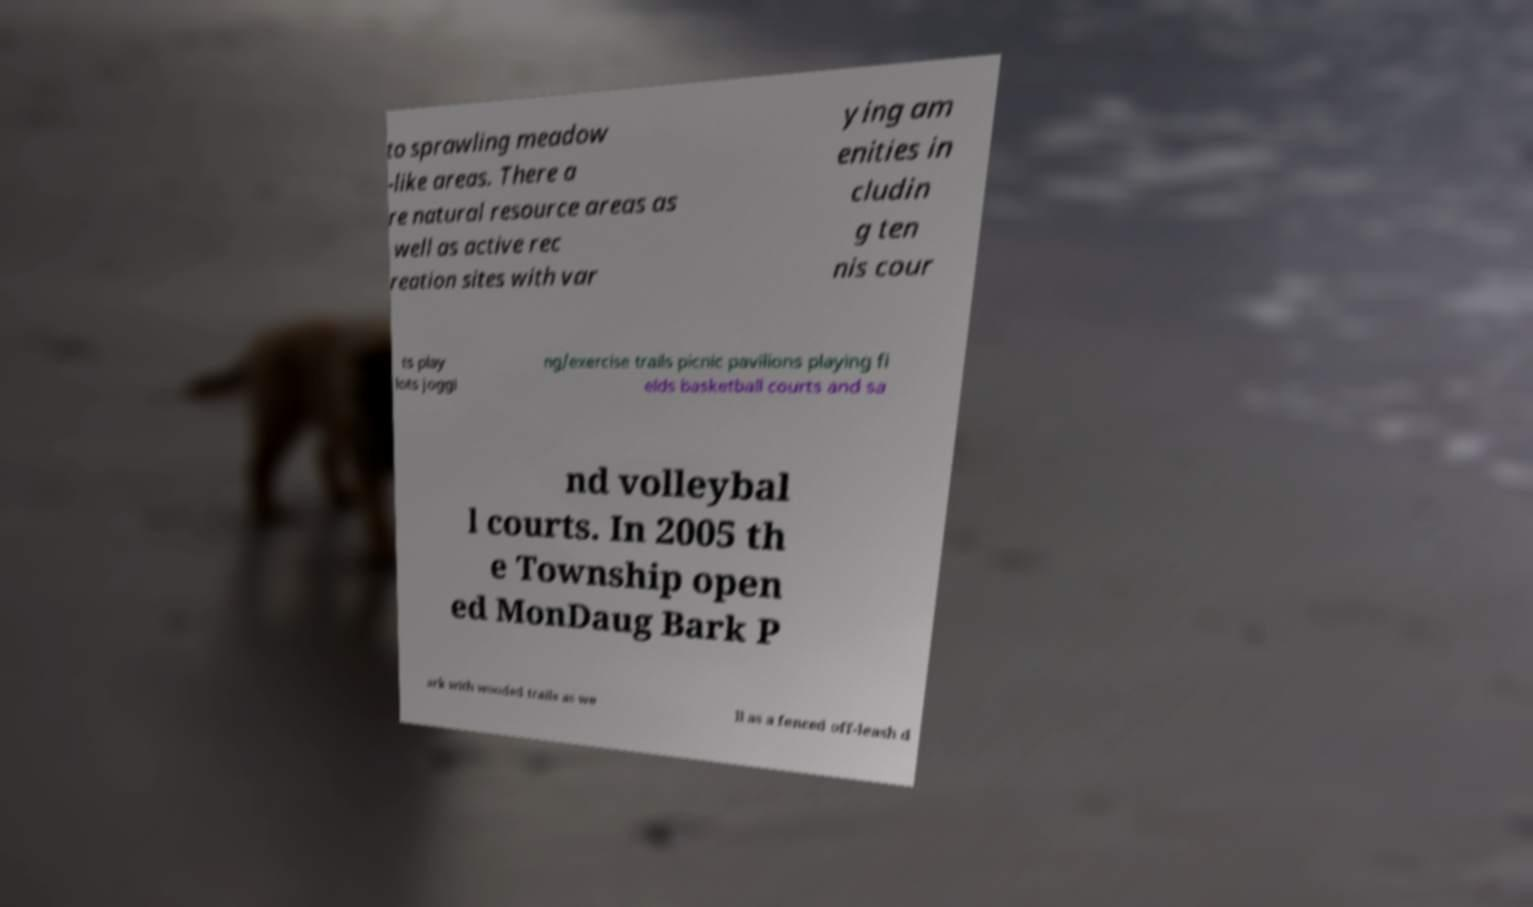Can you accurately transcribe the text from the provided image for me? to sprawling meadow -like areas. There a re natural resource areas as well as active rec reation sites with var ying am enities in cludin g ten nis cour ts play lots joggi ng/exercise trails picnic pavilions playing fi elds basketball courts and sa nd volleybal l courts. In 2005 th e Township open ed MonDaug Bark P ark with wooded trails as we ll as a fenced off-leash d 